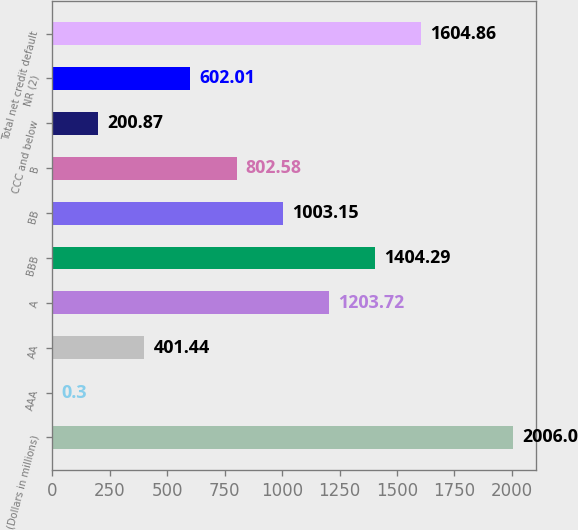Convert chart to OTSL. <chart><loc_0><loc_0><loc_500><loc_500><bar_chart><fcel>(Dollars in millions)<fcel>AAA<fcel>AA<fcel>A<fcel>BBB<fcel>BB<fcel>B<fcel>CCC and below<fcel>NR (2)<fcel>Total net credit default<nl><fcel>2006<fcel>0.3<fcel>401.44<fcel>1203.72<fcel>1404.29<fcel>1003.15<fcel>802.58<fcel>200.87<fcel>602.01<fcel>1604.86<nl></chart> 